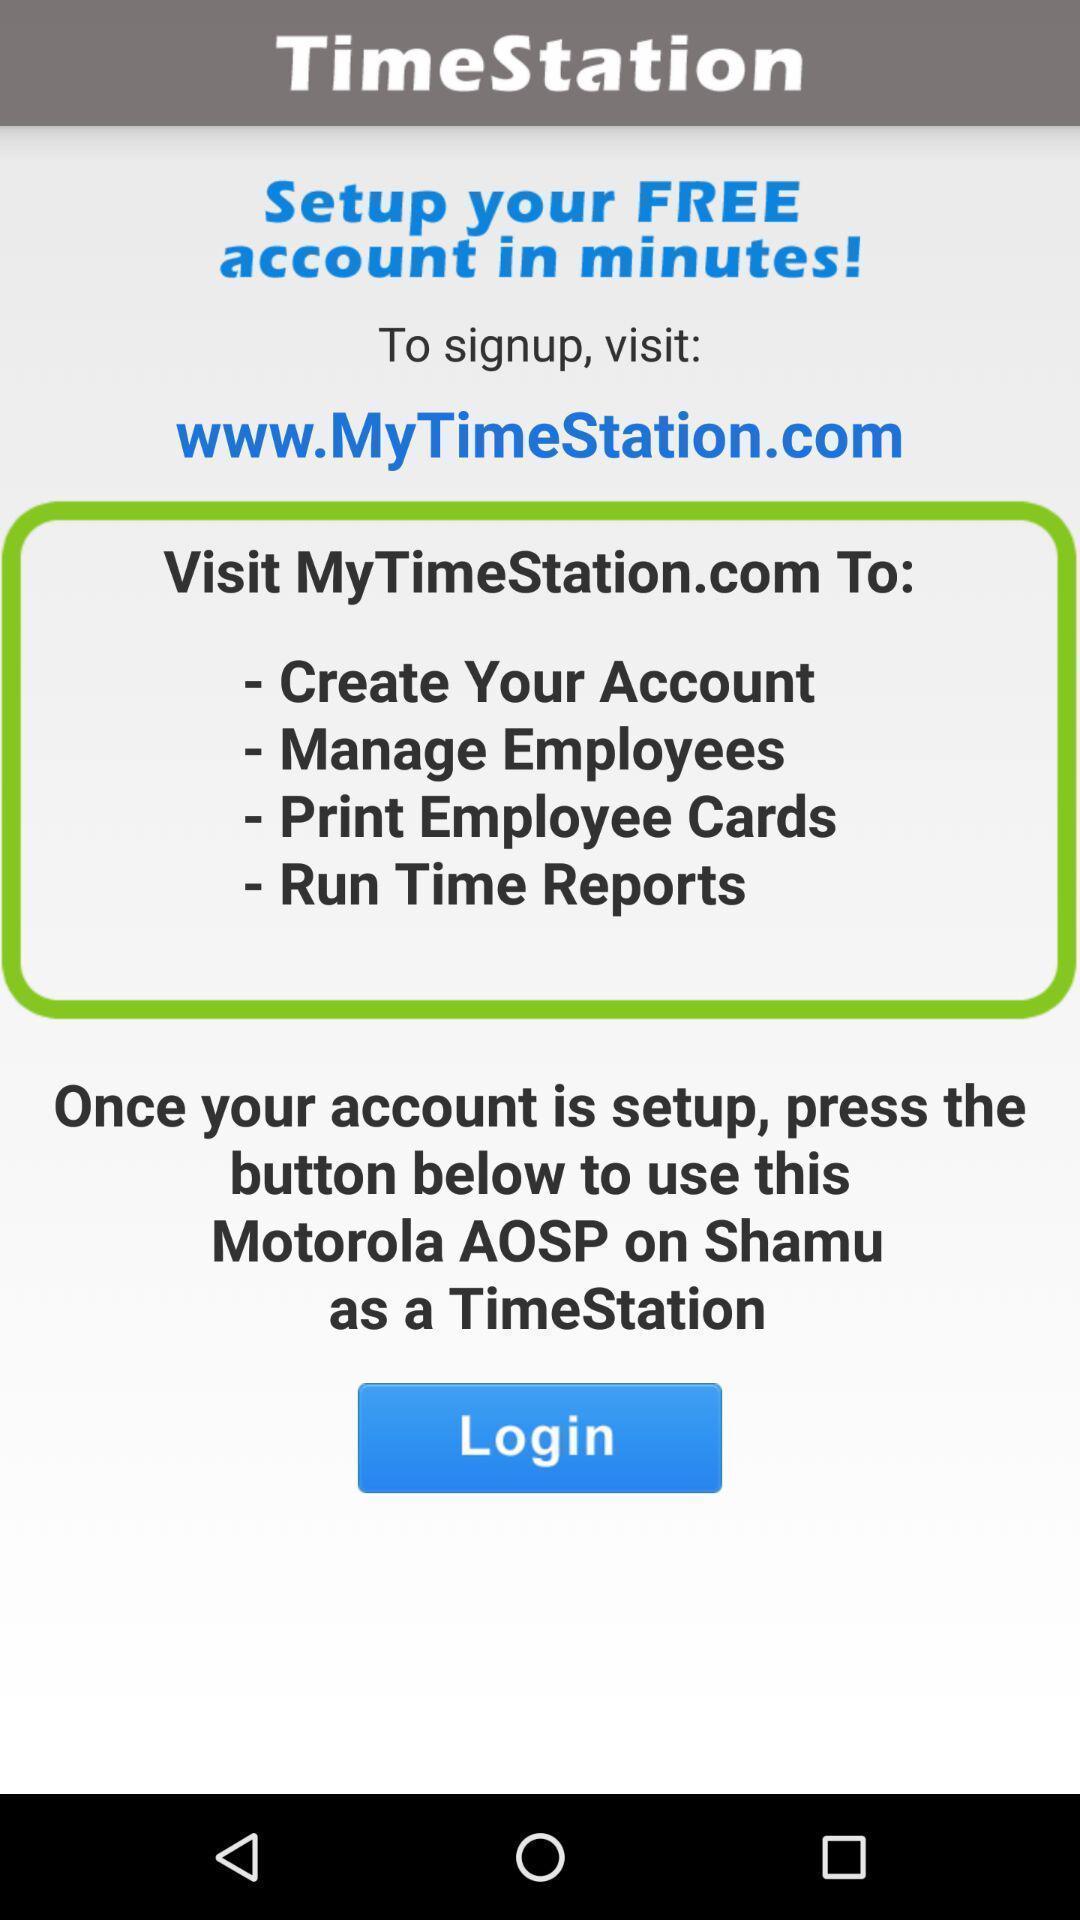Explain what's happening in this screen capture. Page showing instructions for creating account for an application. 